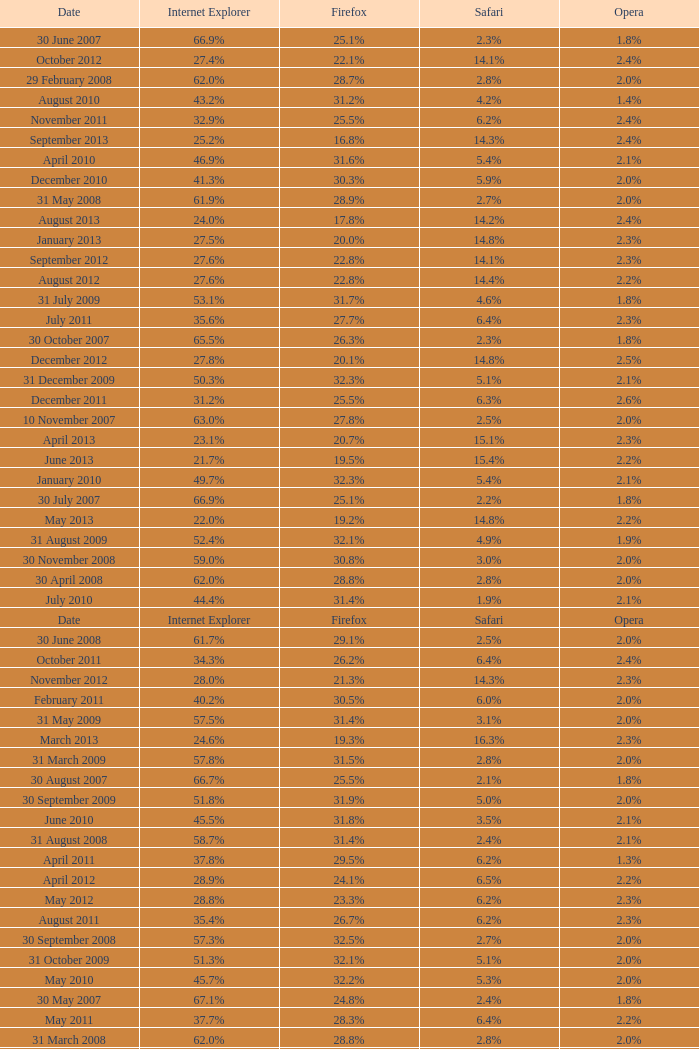What is the safari value with a 2.4% opera and 29.9% internet explorer? 6.5%. 